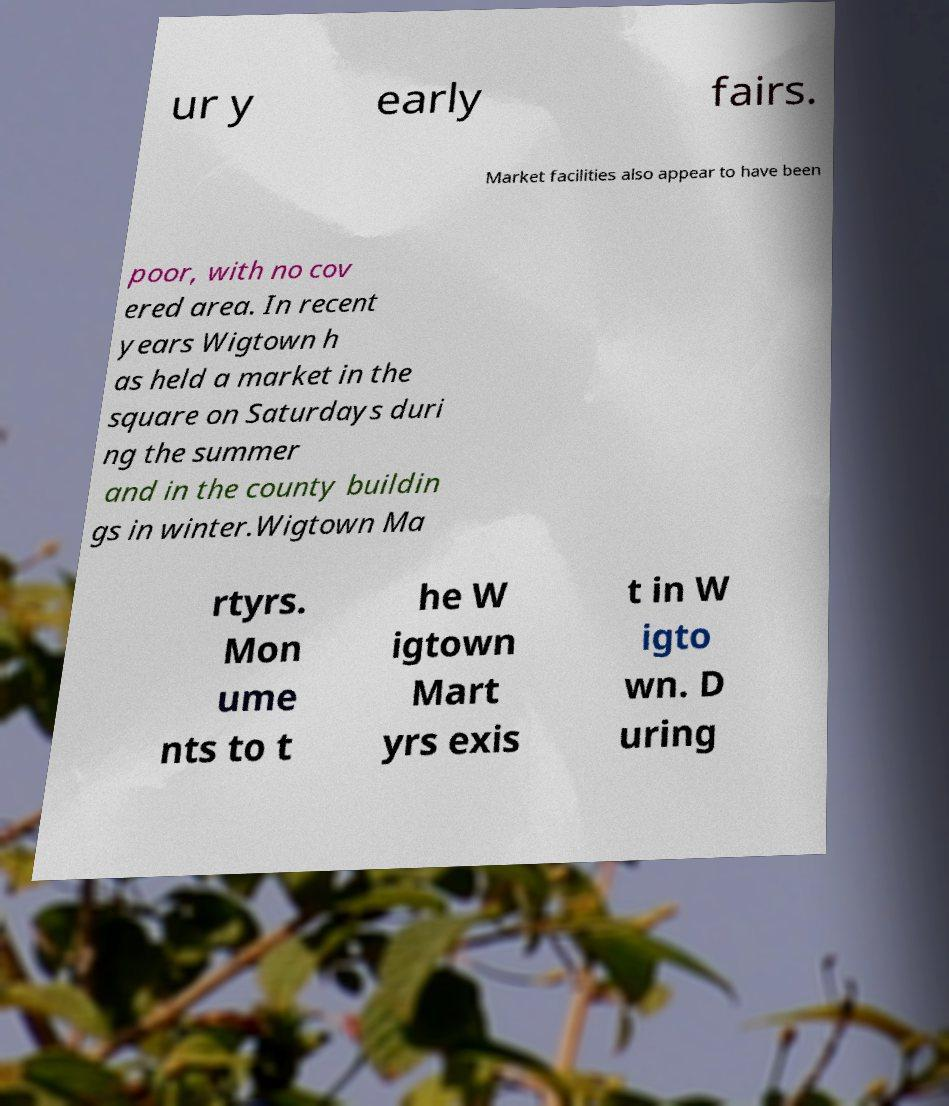I need the written content from this picture converted into text. Can you do that? ur y early fairs. Market facilities also appear to have been poor, with no cov ered area. In recent years Wigtown h as held a market in the square on Saturdays duri ng the summer and in the county buildin gs in winter.Wigtown Ma rtyrs. Mon ume nts to t he W igtown Mart yrs exis t in W igto wn. D uring 